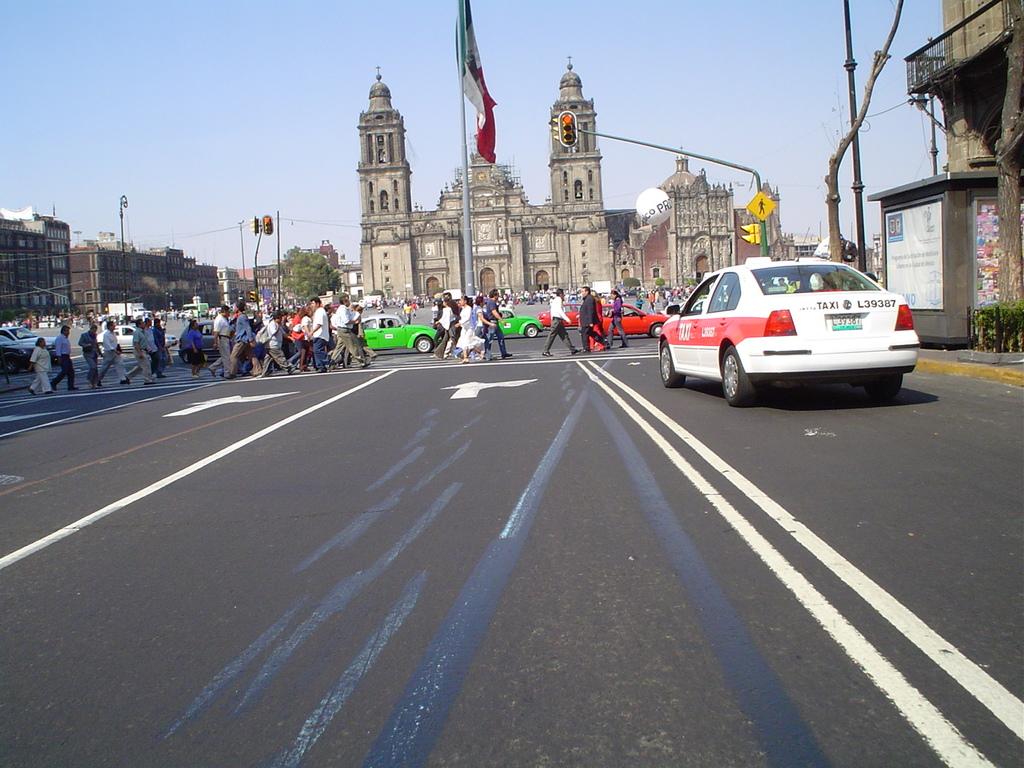What is the last digit of the taxi's taxi number?
Make the answer very short. 7. 